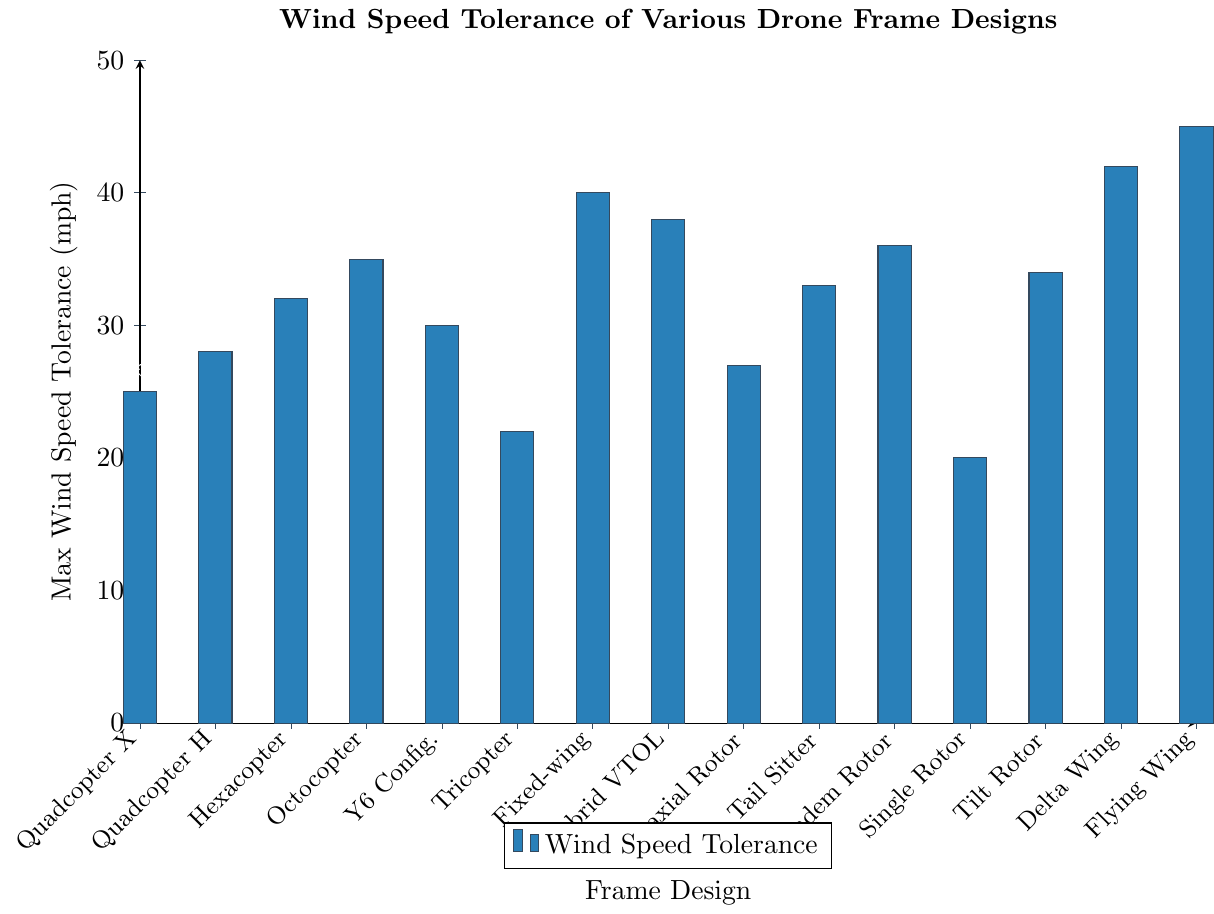Which drone frame design has the highest wind speed tolerance? Locate the highest bar on the chart, which corresponds to the "Flying Wing" with a value of 45 mph.
Answer: Flying Wing What is the wind speed tolerance difference between the Fixed-wing and Tricopter designs? Find the bars for Fixed-wing and Tricopter, which have values of 40 mph and 22 mph, respectively. Compute the difference (40 - 22).
Answer: 18 mph What is the average wind speed tolerance for the Quadcopter X, Octocopter, and Delta Wing designs? Look at the wind speed tolerance values: Quadcopter X (25), Octocopter (35), Delta Wing (42). Add them up (25 + 35 + 42) and divide by 3.
Answer: 34 mph Are there any frame designs with the same wind speed tolerance? Check all bars and their corresponding values. Verify there are no duplicate values in the chart.
Answer: No Which frame design has a lower wind speed tolerance: Coaxial Rotor or Tail Sitter? Locate Coaxial Rotor and Tail Sitter on the chart with values of 27 mph and 33 mph, respectively. Compare the values.
Answer: Coaxial Rotor What is the total wind speed tolerance for all Tricopter, Single Rotor, and Hexacopter designs combined? Add the values for Tricopter (22), Single Rotor (20), and Hexacopter (32).
Answer: 74 mph How many frame designs can tolerate wind speeds of 35 mph or higher? Identify the frame designs with wind speed tolerances of 35 mph or higher: Octocopter (35), Tail Sitter (33), Tandem Rotor (36), Tilt Rotor (34), Delta Wing (42), Flying Wing (45). Then count the qualifying designs.
Answer: 5 What is the difference in wind speed tolerance between the Y6 Configuration and Hybrid VTOL designs? Identify the values for Y6 Configuration (30 mph) and Hybrid VTOL (38 mph). Calculate the difference (38 - 30).
Answer: 8 mph Which frame design is depicted by the shortest bar on the chart? Locate the shortest bar, which corresponds to the Single Rotor design with a value of 20 mph.
Answer: Single Rotor What is the median wind speed tolerance value among all the frame designs? List the values, sort them: 20, 22, 25, 27, 28, 30, 32, 33, 34, 35, 36, 38, 40, 42, 45. Identify the middle value in this sorted list.
Answer: 33 mph 